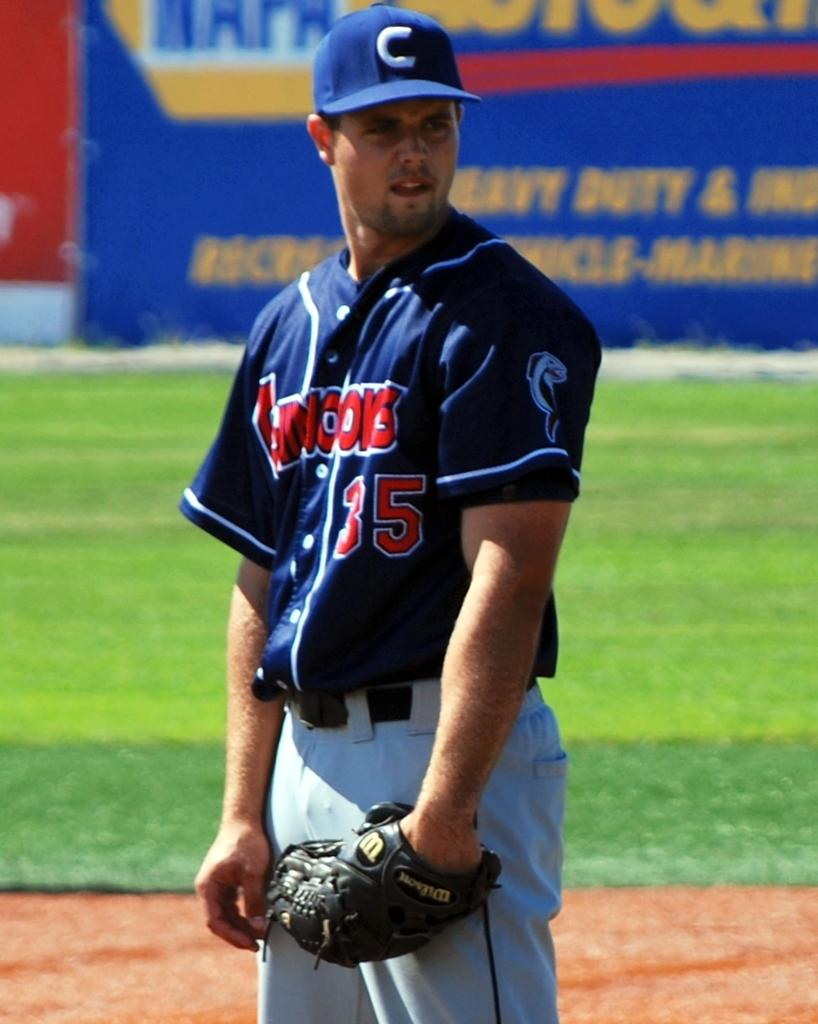<image>
Share a concise interpretation of the image provided. A baseball player with the number 35 on his shirt 